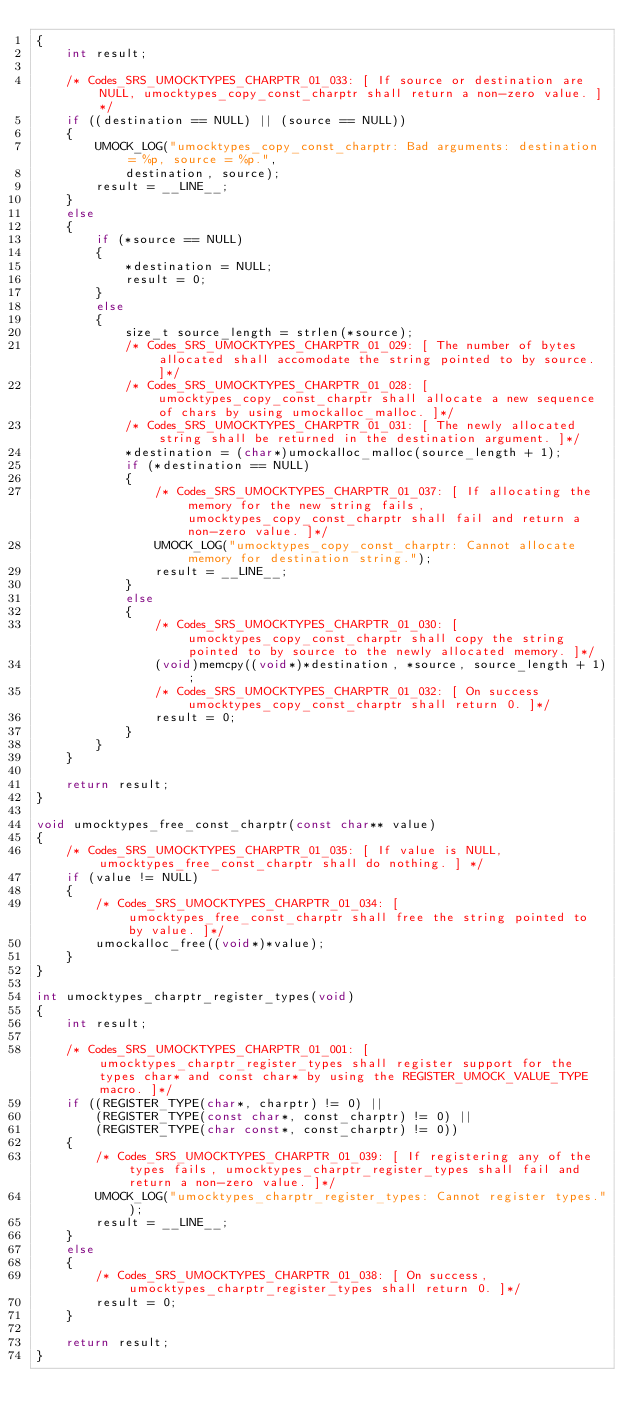<code> <loc_0><loc_0><loc_500><loc_500><_C_>{
    int result;

    /* Codes_SRS_UMOCKTYPES_CHARPTR_01_033: [ If source or destination are NULL, umocktypes_copy_const_charptr shall return a non-zero value. ]*/
    if ((destination == NULL) || (source == NULL))
    {
        UMOCK_LOG("umocktypes_copy_const_charptr: Bad arguments: destination = %p, source = %p.",
            destination, source);
        result = __LINE__;
    }
    else
    {
        if (*source == NULL)
        {
            *destination = NULL;
            result = 0;
        }
        else
        {
            size_t source_length = strlen(*source);
            /* Codes_SRS_UMOCKTYPES_CHARPTR_01_029: [ The number of bytes allocated shall accomodate the string pointed to by source. ]*/
            /* Codes_SRS_UMOCKTYPES_CHARPTR_01_028: [ umocktypes_copy_const_charptr shall allocate a new sequence of chars by using umockalloc_malloc. ]*/
            /* Codes_SRS_UMOCKTYPES_CHARPTR_01_031: [ The newly allocated string shall be returned in the destination argument. ]*/
            *destination = (char*)umockalloc_malloc(source_length + 1);
            if (*destination == NULL)
            {
                /* Codes_SRS_UMOCKTYPES_CHARPTR_01_037: [ If allocating the memory for the new string fails, umocktypes_copy_const_charptr shall fail and return a non-zero value. ]*/
                UMOCK_LOG("umocktypes_copy_const_charptr: Cannot allocate memory for destination string.");
                result = __LINE__;
            }
            else
            {
                /* Codes_SRS_UMOCKTYPES_CHARPTR_01_030: [ umocktypes_copy_const_charptr shall copy the string pointed to by source to the newly allocated memory. ]*/
                (void)memcpy((void*)*destination, *source, source_length + 1);
                /* Codes_SRS_UMOCKTYPES_CHARPTR_01_032: [ On success umocktypes_copy_const_charptr shall return 0. ]*/
                result = 0;
            }
        }
    }

    return result;
}

void umocktypes_free_const_charptr(const char** value)
{
    /* Codes_SRS_UMOCKTYPES_CHARPTR_01_035: [ If value is NULL, umocktypes_free_const_charptr shall do nothing. ] */
    if (value != NULL)
    {
        /* Codes_SRS_UMOCKTYPES_CHARPTR_01_034: [ umocktypes_free_const_charptr shall free the string pointed to by value. ]*/
        umockalloc_free((void*)*value);
    }
}

int umocktypes_charptr_register_types(void)
{
    int result;

    /* Codes_SRS_UMOCKTYPES_CHARPTR_01_001: [ umocktypes_charptr_register_types shall register support for the types char* and const char* by using the REGISTER_UMOCK_VALUE_TYPE macro. ]*/
    if ((REGISTER_TYPE(char*, charptr) != 0) ||
        (REGISTER_TYPE(const char*, const_charptr) != 0) ||
        (REGISTER_TYPE(char const*, const_charptr) != 0))
    {
        /* Codes_SRS_UMOCKTYPES_CHARPTR_01_039: [ If registering any of the types fails, umocktypes_charptr_register_types shall fail and return a non-zero value. ]*/
        UMOCK_LOG("umocktypes_charptr_register_types: Cannot register types.");
        result = __LINE__;
    }
    else
    {
        /* Codes_SRS_UMOCKTYPES_CHARPTR_01_038: [ On success, umocktypes_charptr_register_types shall return 0. ]*/
        result = 0;
    }

    return result;
}
</code> 